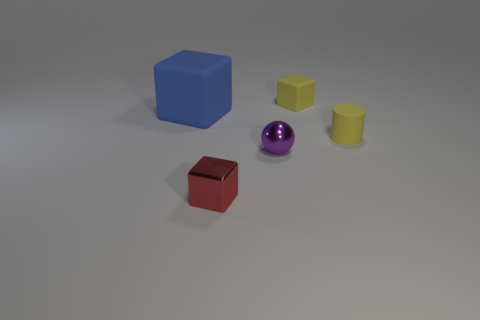How do the shadows in the image inform us about the light source? The shadows are cast to the right and are relatively soft-edged, indicating that the light source is to the left of the objects and not extremely close, resulting in diffused lighting. 